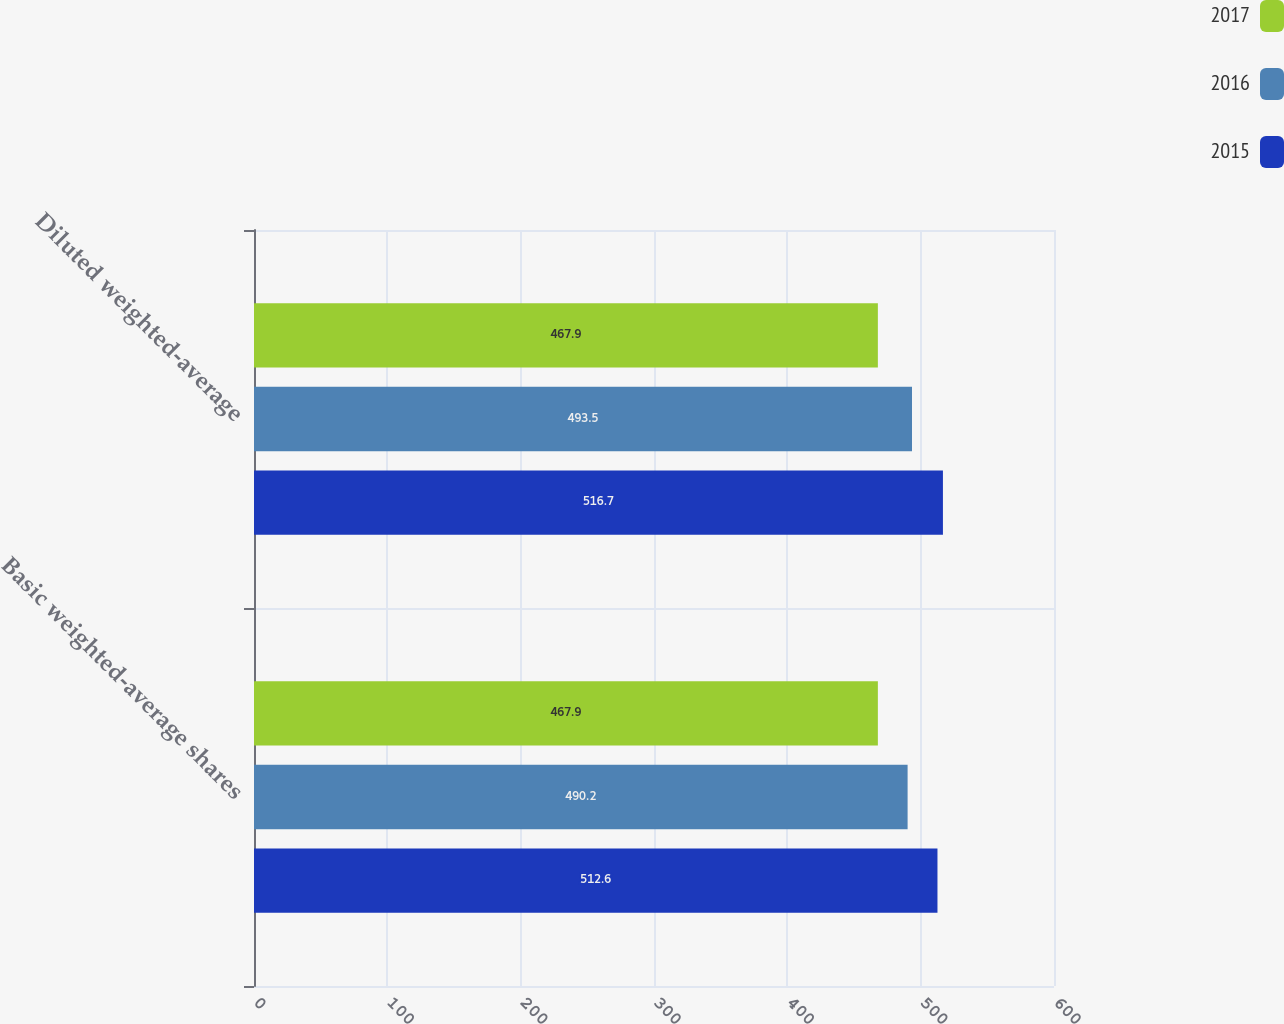Convert chart to OTSL. <chart><loc_0><loc_0><loc_500><loc_500><stacked_bar_chart><ecel><fcel>Basic weighted-average shares<fcel>Diluted weighted-average<nl><fcel>2017<fcel>467.9<fcel>467.9<nl><fcel>2016<fcel>490.2<fcel>493.5<nl><fcel>2015<fcel>512.6<fcel>516.7<nl></chart> 